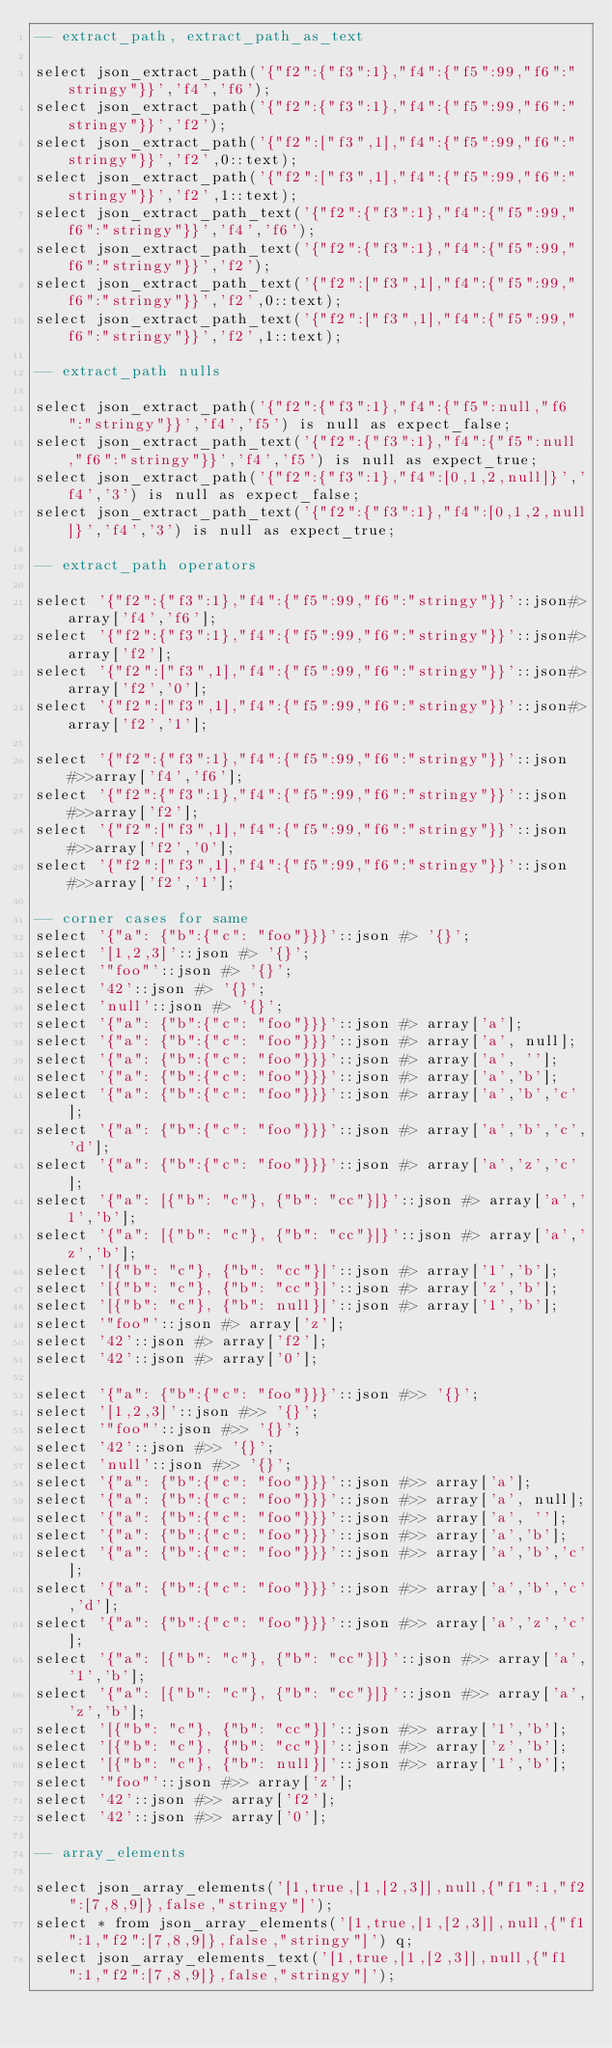<code> <loc_0><loc_0><loc_500><loc_500><_SQL_>-- extract_path, extract_path_as_text

select json_extract_path('{"f2":{"f3":1},"f4":{"f5":99,"f6":"stringy"}}','f4','f6');
select json_extract_path('{"f2":{"f3":1},"f4":{"f5":99,"f6":"stringy"}}','f2');
select json_extract_path('{"f2":["f3",1],"f4":{"f5":99,"f6":"stringy"}}','f2',0::text);
select json_extract_path('{"f2":["f3",1],"f4":{"f5":99,"f6":"stringy"}}','f2',1::text);
select json_extract_path_text('{"f2":{"f3":1},"f4":{"f5":99,"f6":"stringy"}}','f4','f6');
select json_extract_path_text('{"f2":{"f3":1},"f4":{"f5":99,"f6":"stringy"}}','f2');
select json_extract_path_text('{"f2":["f3",1],"f4":{"f5":99,"f6":"stringy"}}','f2',0::text);
select json_extract_path_text('{"f2":["f3",1],"f4":{"f5":99,"f6":"stringy"}}','f2',1::text);

-- extract_path nulls

select json_extract_path('{"f2":{"f3":1},"f4":{"f5":null,"f6":"stringy"}}','f4','f5') is null as expect_false;
select json_extract_path_text('{"f2":{"f3":1},"f4":{"f5":null,"f6":"stringy"}}','f4','f5') is null as expect_true;
select json_extract_path('{"f2":{"f3":1},"f4":[0,1,2,null]}','f4','3') is null as expect_false;
select json_extract_path_text('{"f2":{"f3":1},"f4":[0,1,2,null]}','f4','3') is null as expect_true;

-- extract_path operators

select '{"f2":{"f3":1},"f4":{"f5":99,"f6":"stringy"}}'::json#>array['f4','f6'];
select '{"f2":{"f3":1},"f4":{"f5":99,"f6":"stringy"}}'::json#>array['f2'];
select '{"f2":["f3",1],"f4":{"f5":99,"f6":"stringy"}}'::json#>array['f2','0'];
select '{"f2":["f3",1],"f4":{"f5":99,"f6":"stringy"}}'::json#>array['f2','1'];

select '{"f2":{"f3":1},"f4":{"f5":99,"f6":"stringy"}}'::json#>>array['f4','f6'];
select '{"f2":{"f3":1},"f4":{"f5":99,"f6":"stringy"}}'::json#>>array['f2'];
select '{"f2":["f3",1],"f4":{"f5":99,"f6":"stringy"}}'::json#>>array['f2','0'];
select '{"f2":["f3",1],"f4":{"f5":99,"f6":"stringy"}}'::json#>>array['f2','1'];

-- corner cases for same
select '{"a": {"b":{"c": "foo"}}}'::json #> '{}';
select '[1,2,3]'::json #> '{}';
select '"foo"'::json #> '{}';
select '42'::json #> '{}';
select 'null'::json #> '{}';
select '{"a": {"b":{"c": "foo"}}}'::json #> array['a'];
select '{"a": {"b":{"c": "foo"}}}'::json #> array['a', null];
select '{"a": {"b":{"c": "foo"}}}'::json #> array['a', ''];
select '{"a": {"b":{"c": "foo"}}}'::json #> array['a','b'];
select '{"a": {"b":{"c": "foo"}}}'::json #> array['a','b','c'];
select '{"a": {"b":{"c": "foo"}}}'::json #> array['a','b','c','d'];
select '{"a": {"b":{"c": "foo"}}}'::json #> array['a','z','c'];
select '{"a": [{"b": "c"}, {"b": "cc"}]}'::json #> array['a','1','b'];
select '{"a": [{"b": "c"}, {"b": "cc"}]}'::json #> array['a','z','b'];
select '[{"b": "c"}, {"b": "cc"}]'::json #> array['1','b'];
select '[{"b": "c"}, {"b": "cc"}]'::json #> array['z','b'];
select '[{"b": "c"}, {"b": null}]'::json #> array['1','b'];
select '"foo"'::json #> array['z'];
select '42'::json #> array['f2'];
select '42'::json #> array['0'];

select '{"a": {"b":{"c": "foo"}}}'::json #>> '{}';
select '[1,2,3]'::json #>> '{}';
select '"foo"'::json #>> '{}';
select '42'::json #>> '{}';
select 'null'::json #>> '{}';
select '{"a": {"b":{"c": "foo"}}}'::json #>> array['a'];
select '{"a": {"b":{"c": "foo"}}}'::json #>> array['a', null];
select '{"a": {"b":{"c": "foo"}}}'::json #>> array['a', ''];
select '{"a": {"b":{"c": "foo"}}}'::json #>> array['a','b'];
select '{"a": {"b":{"c": "foo"}}}'::json #>> array['a','b','c'];
select '{"a": {"b":{"c": "foo"}}}'::json #>> array['a','b','c','d'];
select '{"a": {"b":{"c": "foo"}}}'::json #>> array['a','z','c'];
select '{"a": [{"b": "c"}, {"b": "cc"}]}'::json #>> array['a','1','b'];
select '{"a": [{"b": "c"}, {"b": "cc"}]}'::json #>> array['a','z','b'];
select '[{"b": "c"}, {"b": "cc"}]'::json #>> array['1','b'];
select '[{"b": "c"}, {"b": "cc"}]'::json #>> array['z','b'];
select '[{"b": "c"}, {"b": null}]'::json #>> array['1','b'];
select '"foo"'::json #>> array['z'];
select '42'::json #>> array['f2'];
select '42'::json #>> array['0'];

-- array_elements

select json_array_elements('[1,true,[1,[2,3]],null,{"f1":1,"f2":[7,8,9]},false,"stringy"]');
select * from json_array_elements('[1,true,[1,[2,3]],null,{"f1":1,"f2":[7,8,9]},false,"stringy"]') q;
select json_array_elements_text('[1,true,[1,[2,3]],null,{"f1":1,"f2":[7,8,9]},false,"stringy"]');</code> 